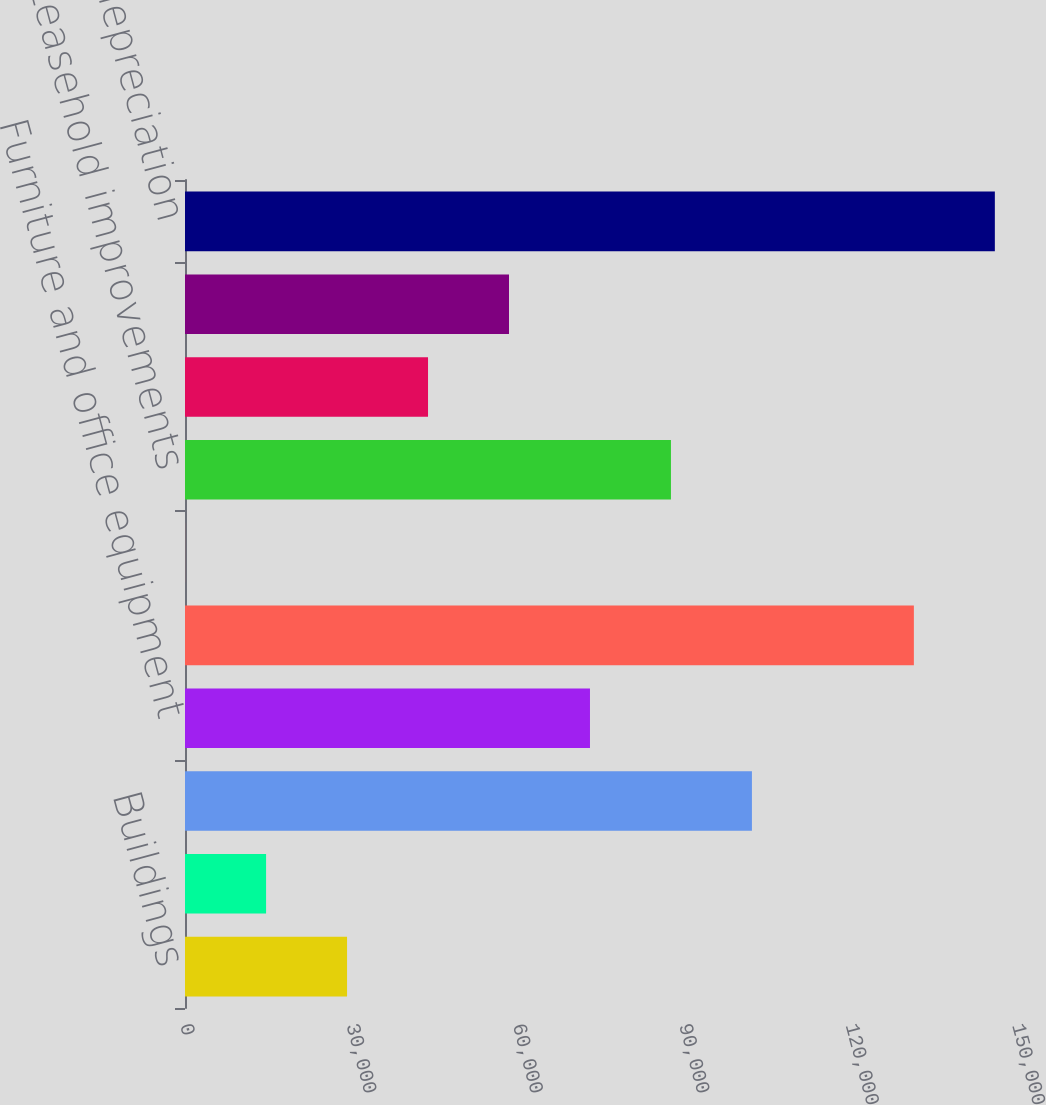Convert chart. <chart><loc_0><loc_0><loc_500><loc_500><bar_chart><fcel>Buildings<fcel>Land<fcel>Machinery equipment and<fcel>Furniture and office equipment<fcel>Computers and software<fcel>Automobiles<fcel>Leasehold improvements<fcel>Projects in progress -<fcel>Projects in progress - other<fcel>Less accumulated depreciation<nl><fcel>29215.8<fcel>14616.9<fcel>102210<fcel>73012.5<fcel>131408<fcel>18<fcel>87611.4<fcel>43814.7<fcel>58413.6<fcel>146007<nl></chart> 